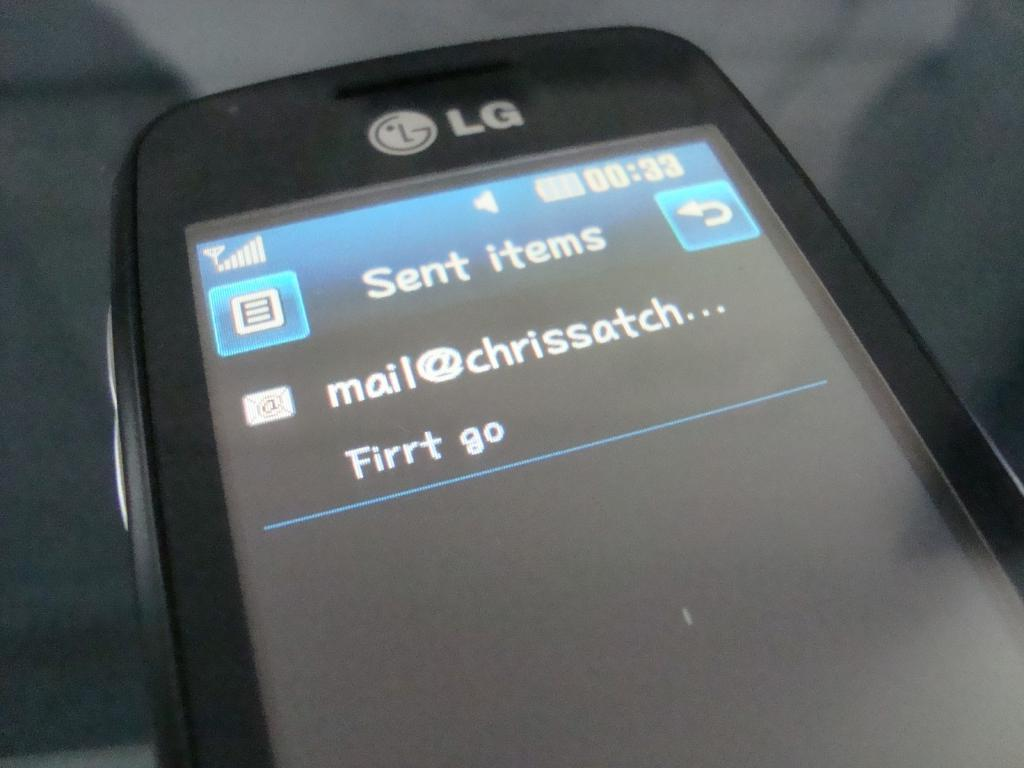<image>
Present a compact description of the photo's key features. Someone with an LG phone sent an email to Chris. 